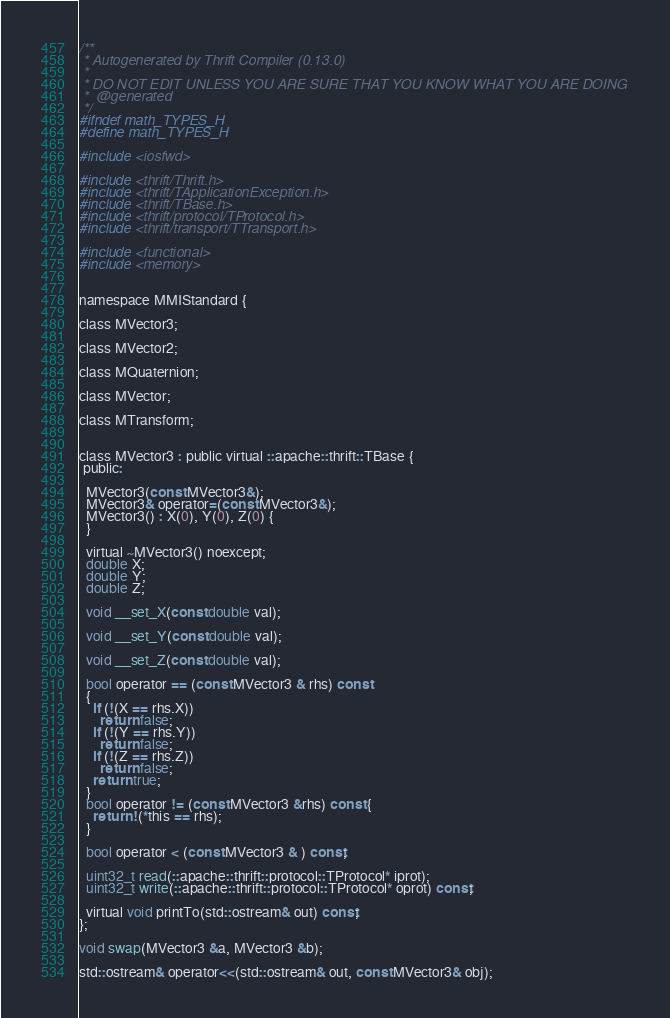<code> <loc_0><loc_0><loc_500><loc_500><_C_>/**
 * Autogenerated by Thrift Compiler (0.13.0)
 *
 * DO NOT EDIT UNLESS YOU ARE SURE THAT YOU KNOW WHAT YOU ARE DOING
 *  @generated
 */
#ifndef math_TYPES_H
#define math_TYPES_H

#include <iosfwd>

#include <thrift/Thrift.h>
#include <thrift/TApplicationException.h>
#include <thrift/TBase.h>
#include <thrift/protocol/TProtocol.h>
#include <thrift/transport/TTransport.h>

#include <functional>
#include <memory>


namespace MMIStandard {

class MVector3;

class MVector2;

class MQuaternion;

class MVector;

class MTransform;


class MVector3 : public virtual ::apache::thrift::TBase {
 public:

  MVector3(const MVector3&);
  MVector3& operator=(const MVector3&);
  MVector3() : X(0), Y(0), Z(0) {
  }

  virtual ~MVector3() noexcept;
  double X;
  double Y;
  double Z;

  void __set_X(const double val);

  void __set_Y(const double val);

  void __set_Z(const double val);

  bool operator == (const MVector3 & rhs) const
  {
    if (!(X == rhs.X))
      return false;
    if (!(Y == rhs.Y))
      return false;
    if (!(Z == rhs.Z))
      return false;
    return true;
  }
  bool operator != (const MVector3 &rhs) const {
    return !(*this == rhs);
  }

  bool operator < (const MVector3 & ) const;

  uint32_t read(::apache::thrift::protocol::TProtocol* iprot);
  uint32_t write(::apache::thrift::protocol::TProtocol* oprot) const;

  virtual void printTo(std::ostream& out) const;
};

void swap(MVector3 &a, MVector3 &b);

std::ostream& operator<<(std::ostream& out, const MVector3& obj);

</code> 